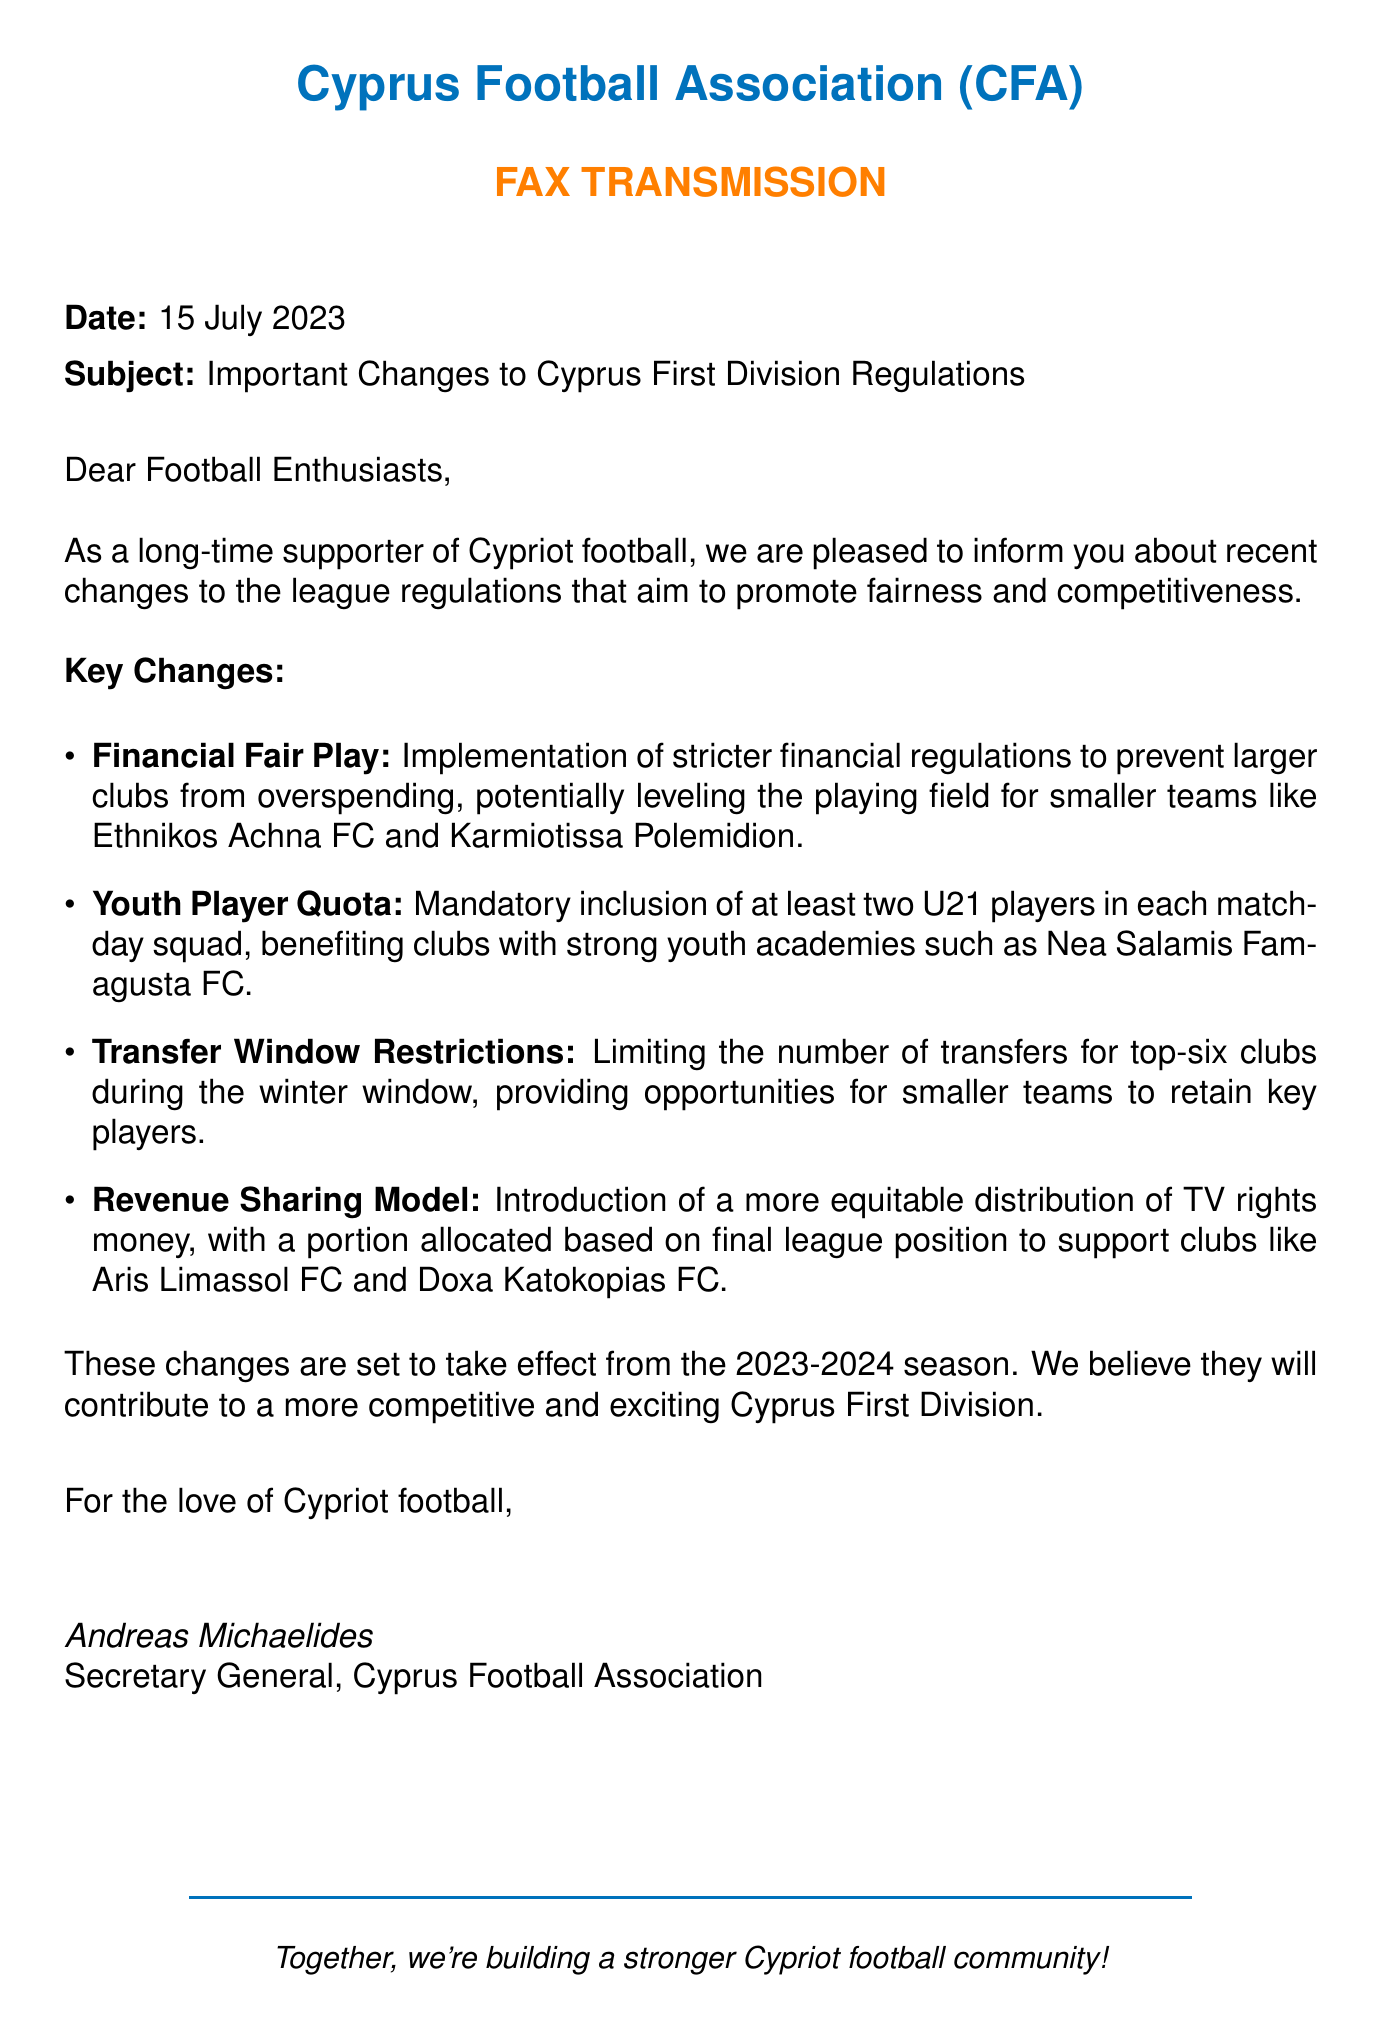What is the date of the fax? The date of the fax is stated clearly in the document's subject line.
Answer: 15 July 2023 Who is the Secretary General of the Cyprus Football Association? The Secretary General is mentioned at the end of the document.
Answer: Andreas Michaelides What is one of the key changes implemented in the league regulations? The document lists multiple key changes in bullet points.
Answer: Financial Fair Play How many U21 players must be included in each matchday squad? The document specifies the number of U21 players required.
Answer: two Which clubs are mentioned as benefiting from the new revenue sharing model? The document explicitly names clubs that will benefit from this model.
Answer: Aris Limassol FC and Doxa Katokopias FC What season will the changes take effect? The document mentions the season in its content when discussing implementation.
Answer: 2023-2024 What is the purpose of the new regulations? The document outlines the aim of these changes in its introduction.
Answer: Promote fairness and competitiveness What restriction is placed on top-six clubs during the winter transfer window? The document specifies the limitation imposed on top-six clubs.
Answer: Limiting the number of transfers 